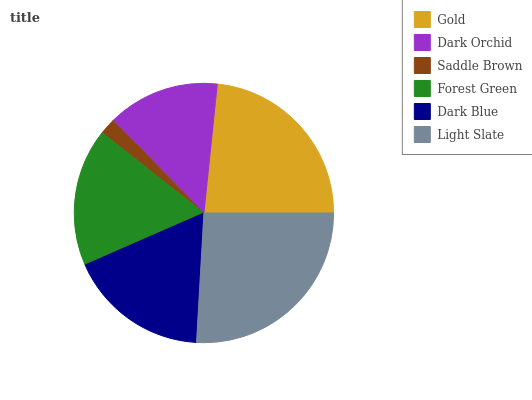Is Saddle Brown the minimum?
Answer yes or no. Yes. Is Light Slate the maximum?
Answer yes or no. Yes. Is Dark Orchid the minimum?
Answer yes or no. No. Is Dark Orchid the maximum?
Answer yes or no. No. Is Gold greater than Dark Orchid?
Answer yes or no. Yes. Is Dark Orchid less than Gold?
Answer yes or no. Yes. Is Dark Orchid greater than Gold?
Answer yes or no. No. Is Gold less than Dark Orchid?
Answer yes or no. No. Is Dark Blue the high median?
Answer yes or no. Yes. Is Forest Green the low median?
Answer yes or no. Yes. Is Saddle Brown the high median?
Answer yes or no. No. Is Gold the low median?
Answer yes or no. No. 